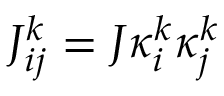Convert formula to latex. <formula><loc_0><loc_0><loc_500><loc_500>J _ { i j } ^ { k } = J \kappa _ { i } ^ { k } \kappa _ { j } ^ { k }</formula> 